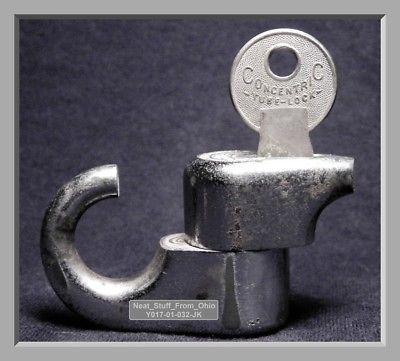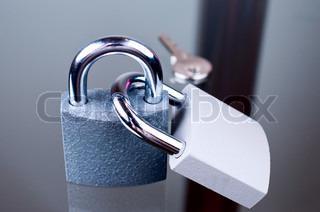The first image is the image on the left, the second image is the image on the right. Evaluate the accuracy of this statement regarding the images: "The right image has at least two keys.". Is it true? Answer yes or no. No. The first image is the image on the left, the second image is the image on the right. Examine the images to the left and right. Is the description "There are two separate keys inserted into the locks." accurate? Answer yes or no. No. 